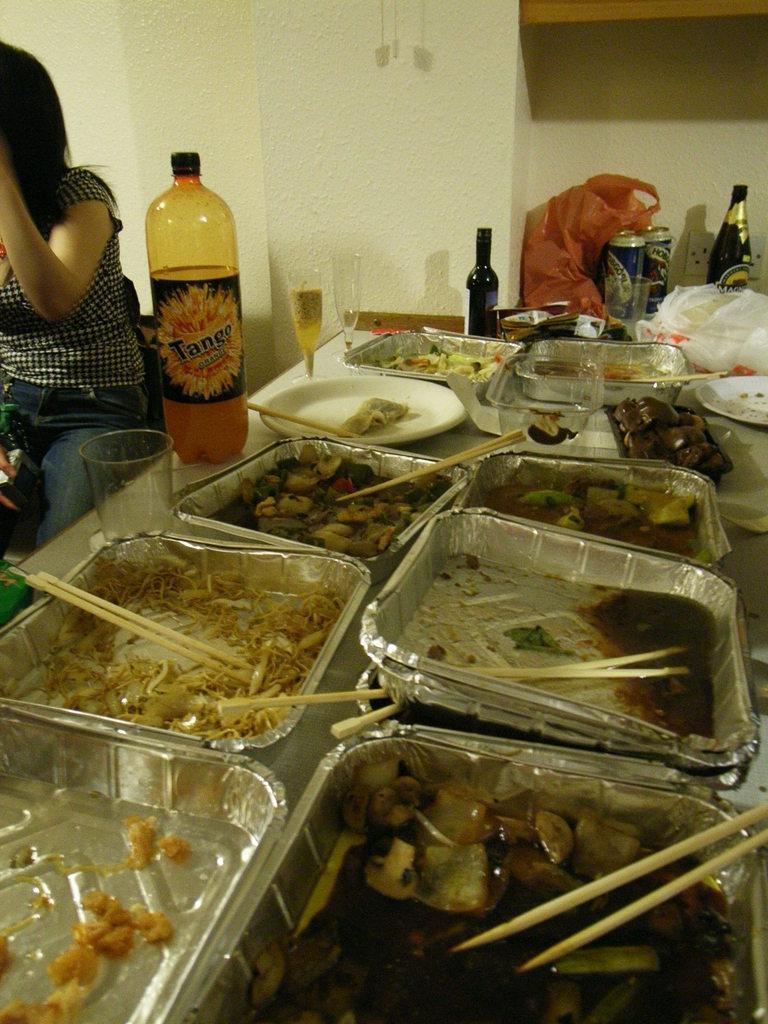Describe this image in one or two sentences. there is a table with leftover food cool drink bottle and some coke tins and there is a girl sitting beside the table. 